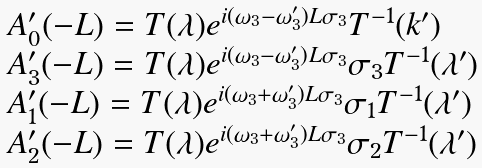Convert formula to latex. <formula><loc_0><loc_0><loc_500><loc_500>\begin{array} { l } A ^ { \prime } _ { 0 } ( - L ) = T ( \lambda ) e ^ { i ( \omega _ { 3 } - \omega _ { 3 } ^ { \prime } ) L \sigma _ { 3 } } T ^ { - 1 } ( k ^ { \prime } ) \\ A ^ { \prime } _ { 3 } ( - L ) = T ( \lambda ) e ^ { i ( \omega _ { 3 } - \omega _ { 3 } ^ { \prime } ) L \sigma _ { 3 } } \sigma _ { 3 } T ^ { - 1 } ( \lambda ^ { \prime } ) \\ A ^ { \prime } _ { 1 } ( - L ) = T ( \lambda ) e ^ { i ( \omega _ { 3 } + \omega _ { 3 } ^ { \prime } ) L \sigma _ { 3 } } \sigma _ { 1 } T ^ { - 1 } ( \lambda ^ { \prime } ) \\ A ^ { \prime } _ { 2 } ( - L ) = T ( \lambda ) e ^ { i ( \omega _ { 3 } + \omega _ { 3 } ^ { \prime } ) L \sigma _ { 3 } } \sigma _ { 2 } T ^ { - 1 } ( \lambda ^ { \prime } ) \quad \end{array}</formula> 